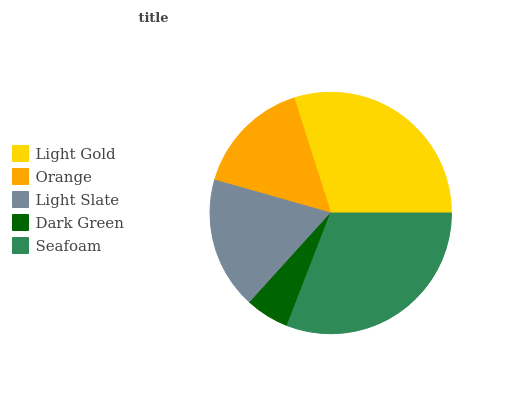Is Dark Green the minimum?
Answer yes or no. Yes. Is Seafoam the maximum?
Answer yes or no. Yes. Is Orange the minimum?
Answer yes or no. No. Is Orange the maximum?
Answer yes or no. No. Is Light Gold greater than Orange?
Answer yes or no. Yes. Is Orange less than Light Gold?
Answer yes or no. Yes. Is Orange greater than Light Gold?
Answer yes or no. No. Is Light Gold less than Orange?
Answer yes or no. No. Is Light Slate the high median?
Answer yes or no. Yes. Is Light Slate the low median?
Answer yes or no. Yes. Is Light Gold the high median?
Answer yes or no. No. Is Orange the low median?
Answer yes or no. No. 